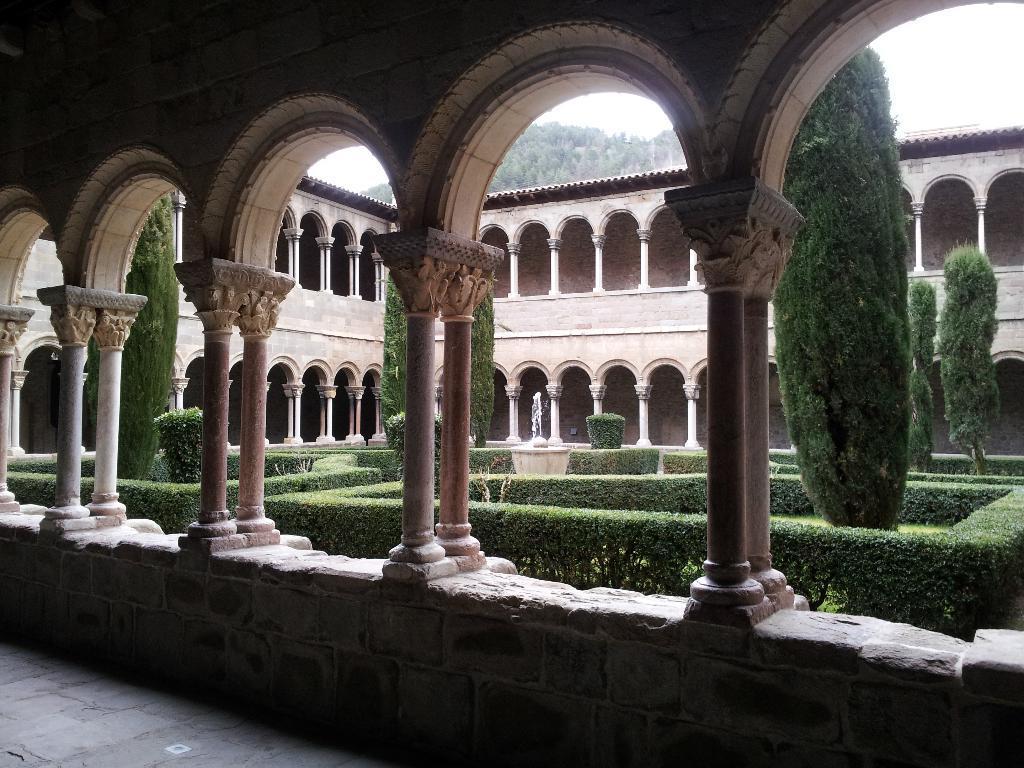In one or two sentences, can you explain what this image depicts? In the image in the center we can see the sky,clouds,trees,plants,grass,buildings,pillars,roof,wall and fountain. 